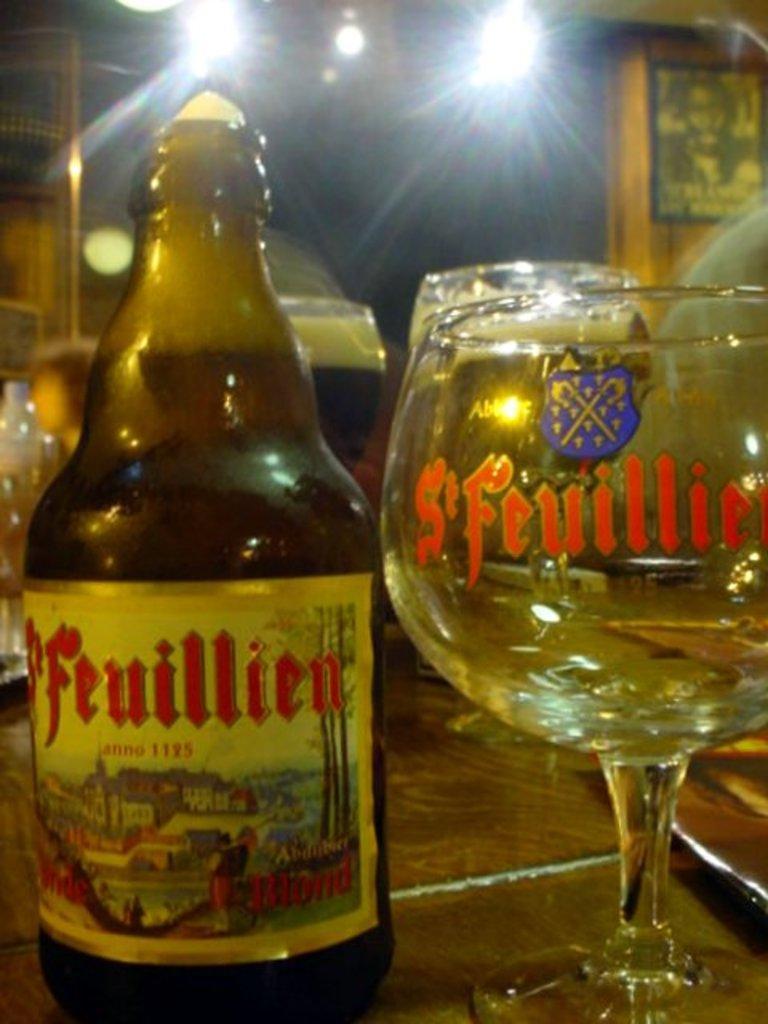Describe this image in one or two sentences. In this image I can see a bottle and the glasses. There is also a light. 